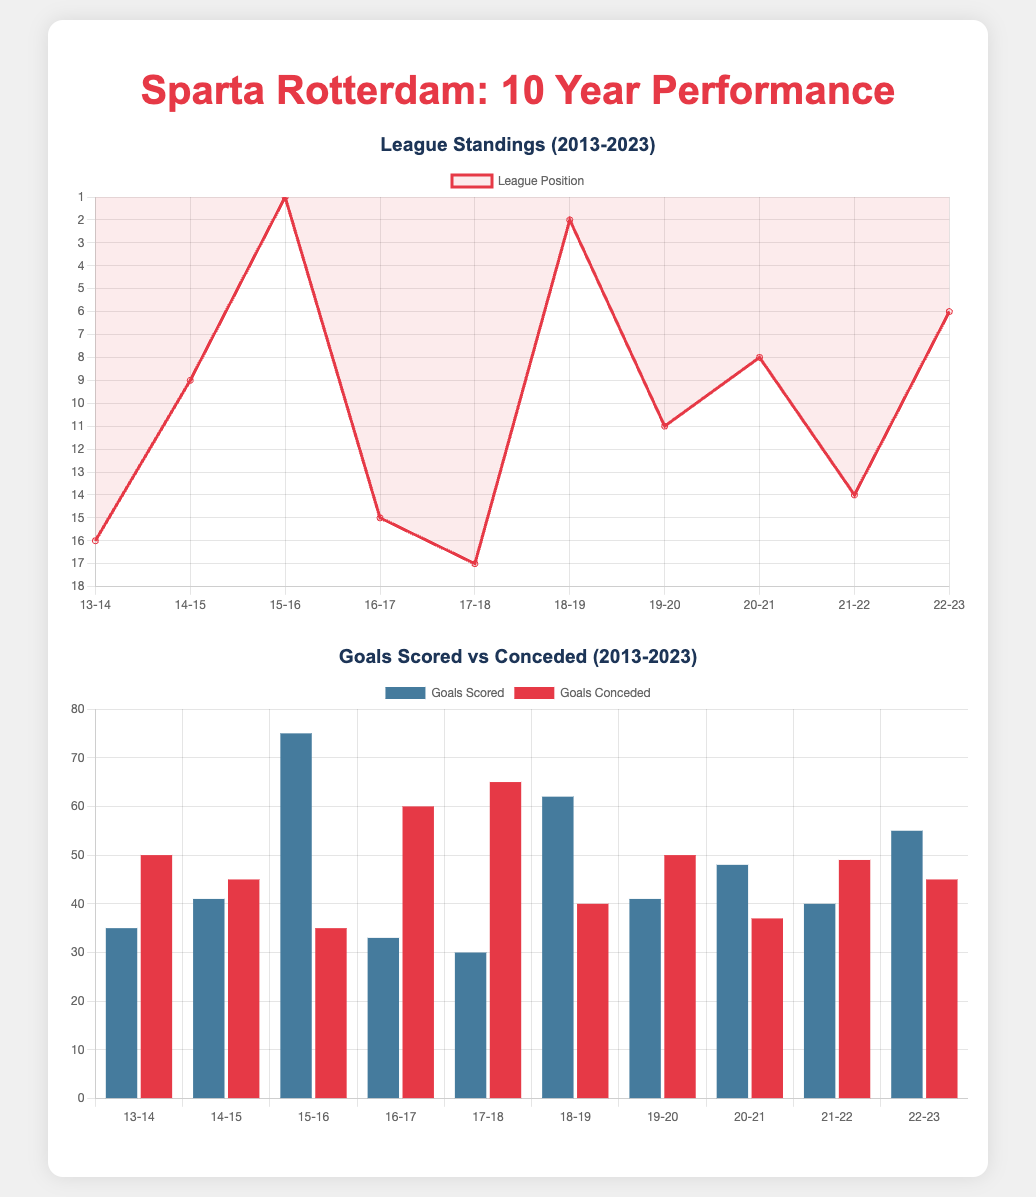What was Sparta Rotterdam's highest league position in the last 10 years? The highest league position is indicated by the lowest number in the standings chart, which is 1.
Answer: 1 What year did Sparta Rotterdam score the most goals? The year with the highest goals scored is determined from the goals scored chart, which shows 75 goals in the season 15-16.
Answer: 75 Which season had the most goals conceded? The most goals conceded is shown in the goals conceded chart, which is 65 in the season 17-18.
Answer: 65 What was Sparta Rotterdam's league position in the 2020-2021 season? The league position for the 2020-2021 season is shown on the standings chart, showing a position of 8.
Answer: 8 How does the number of goals scored in the season 22-23 compare to the season 18-19? The goals scored in 22-23 is 55, while in 18-19 it was 62, indicating a decrease of 7.
Answer: 7 What trend can be observed about the standings over the last decade? The league position trends can be assessed by observing the overall positions listed in the standings chart over the years, which fluctuate but conclude at the 6th position in 22-23.
Answer: Fluctuating Which season's goals scored and conceded have the smallest difference? The smallest difference can be calculated between goals scored and goals conceded in the goals chart for a specific season, which is the season 20-21 with 48 scored and 37 conceded.
Answer: 11 In which season did Sparta Rotterdam achieve a league position of 2? The specific season with a league position of 2 is indicated in the standings chart as the 18-19 season.
Answer: 18-19 What color represents goals scored in the charts? The color representing goals scored is identifiable from the bar chart legends and is represented by a shade of blue.
Answer: Blue 